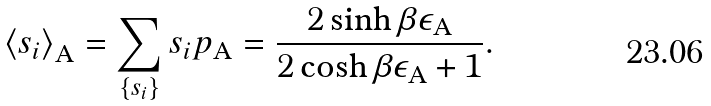<formula> <loc_0><loc_0><loc_500><loc_500>\left \langle s _ { i } \right \rangle _ { \text {A} } = \sum _ { \left \{ s _ { i } \right \} } s _ { i } p _ { \text {A} } = \frac { 2 \sinh \beta \epsilon _ { \text {A} } } { 2 \cosh \beta \epsilon _ { \text {A} } + 1 } .</formula> 